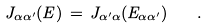Convert formula to latex. <formula><loc_0><loc_0><loc_500><loc_500>J _ { \alpha \alpha ^ { \prime } } ( E ) \, = \, J _ { \alpha ^ { \prime } \alpha } ( E _ { \alpha \alpha ^ { \prime } } ) \quad .</formula> 